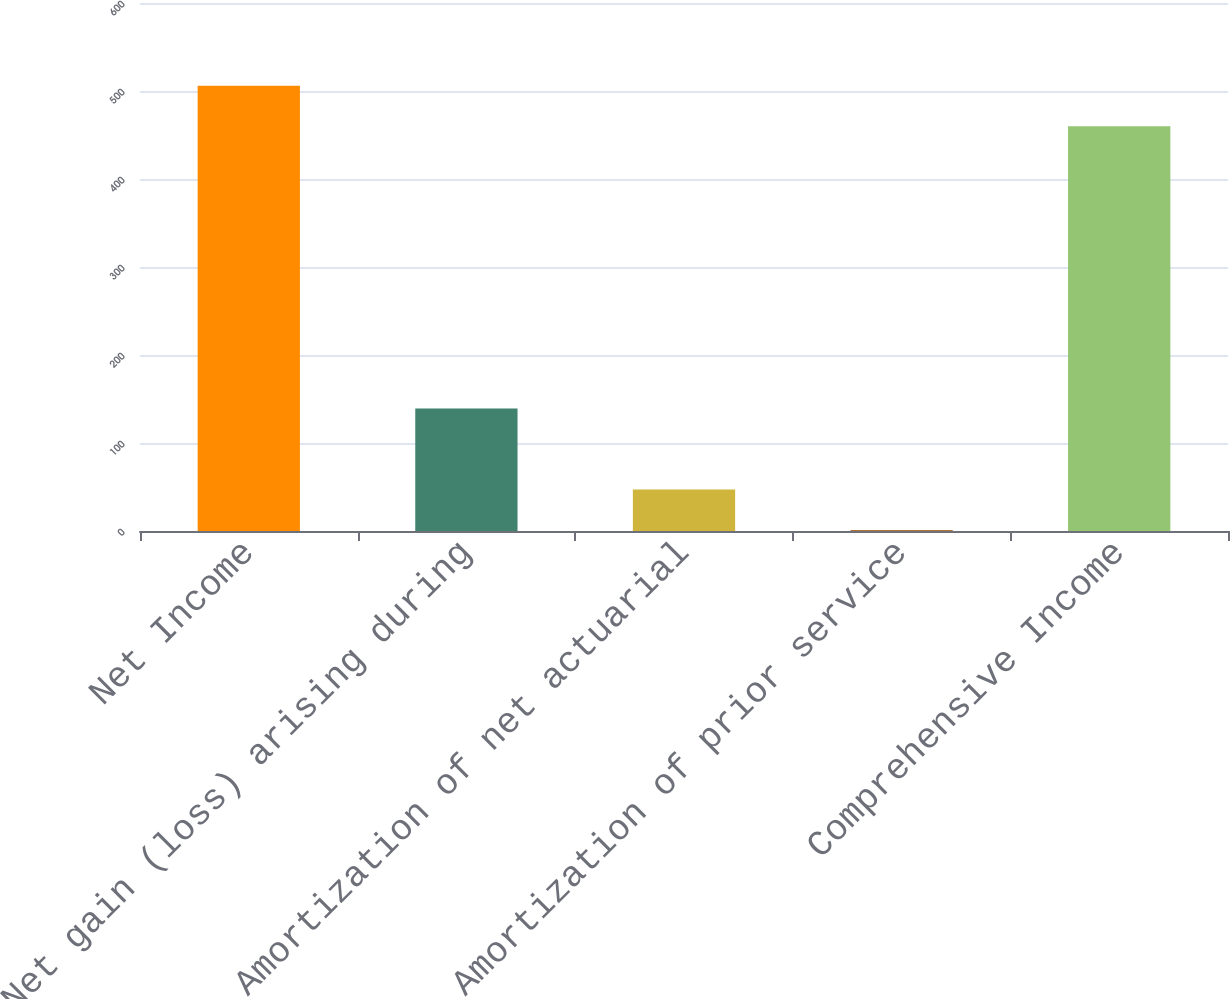Convert chart. <chart><loc_0><loc_0><loc_500><loc_500><bar_chart><fcel>Net Income<fcel>Net gain (loss) arising during<fcel>Amortization of net actuarial<fcel>Amortization of prior service<fcel>Comprehensive Income<nl><fcel>506.1<fcel>139.3<fcel>47.1<fcel>1<fcel>460<nl></chart> 